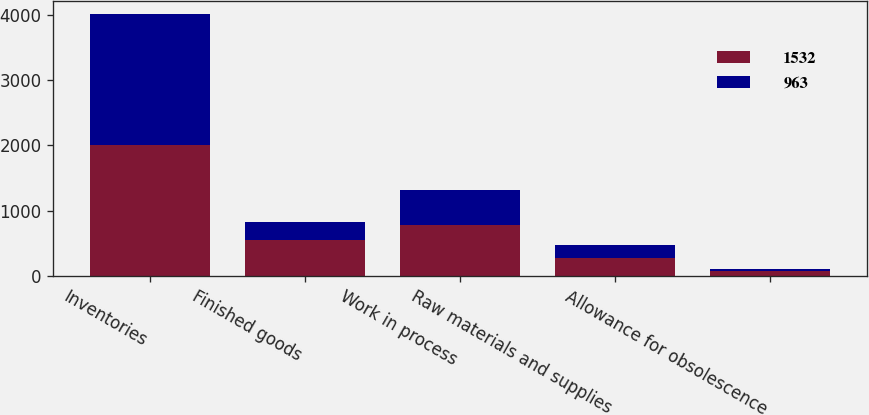<chart> <loc_0><loc_0><loc_500><loc_500><stacked_bar_chart><ecel><fcel>Inventories<fcel>Finished goods<fcel>Work in process<fcel>Raw materials and supplies<fcel>Allowance for obsolescence<nl><fcel>1532<fcel>2007<fcel>547<fcel>784<fcel>271<fcel>70<nl><fcel>963<fcel>2006<fcel>273<fcel>530<fcel>195<fcel>35<nl></chart> 